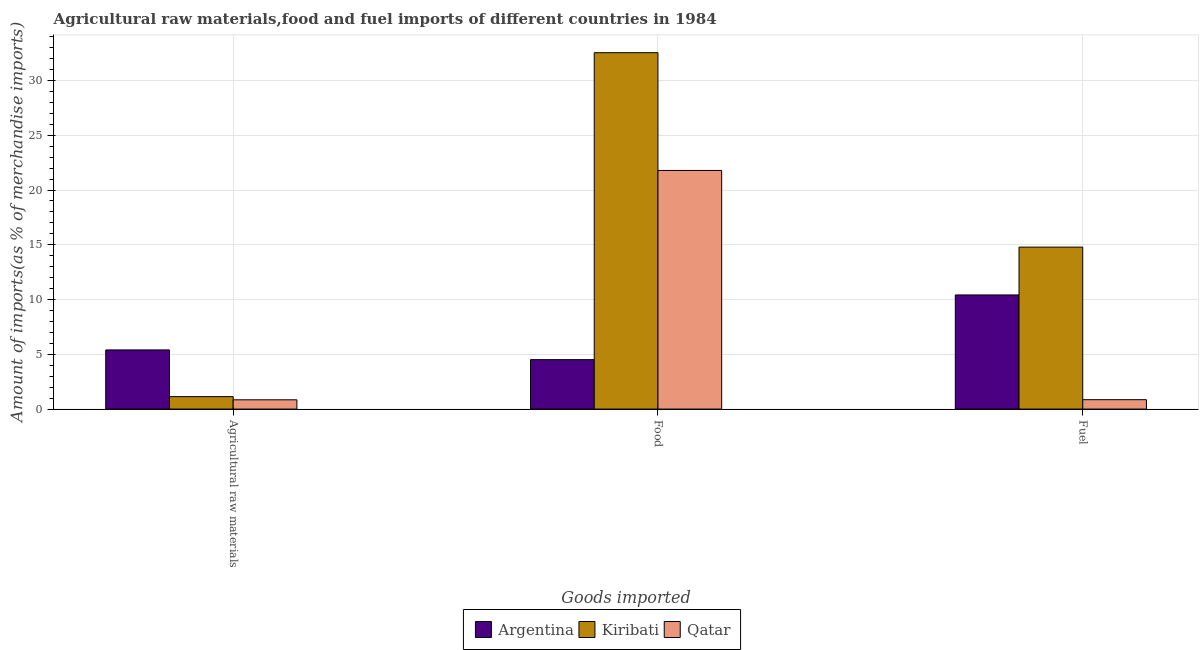How many different coloured bars are there?
Keep it short and to the point. 3. How many bars are there on the 3rd tick from the left?
Keep it short and to the point. 3. How many bars are there on the 2nd tick from the right?
Provide a short and direct response. 3. What is the label of the 1st group of bars from the left?
Your response must be concise. Agricultural raw materials. What is the percentage of fuel imports in Kiribati?
Offer a very short reply. 14.79. Across all countries, what is the maximum percentage of raw materials imports?
Your response must be concise. 5.4. Across all countries, what is the minimum percentage of raw materials imports?
Offer a very short reply. 0.85. In which country was the percentage of raw materials imports minimum?
Make the answer very short. Qatar. What is the total percentage of raw materials imports in the graph?
Keep it short and to the point. 7.39. What is the difference between the percentage of food imports in Kiribati and that in Argentina?
Your answer should be very brief. 28.03. What is the difference between the percentage of food imports in Qatar and the percentage of raw materials imports in Argentina?
Keep it short and to the point. 16.39. What is the average percentage of fuel imports per country?
Provide a succinct answer. 8.69. What is the difference between the percentage of fuel imports and percentage of raw materials imports in Argentina?
Provide a short and direct response. 5.02. In how many countries, is the percentage of food imports greater than 6 %?
Your response must be concise. 2. What is the ratio of the percentage of food imports in Qatar to that in Argentina?
Your answer should be compact. 4.83. Is the difference between the percentage of raw materials imports in Qatar and Kiribati greater than the difference between the percentage of fuel imports in Qatar and Kiribati?
Ensure brevity in your answer.  Yes. What is the difference between the highest and the second highest percentage of raw materials imports?
Keep it short and to the point. 4.26. What is the difference between the highest and the lowest percentage of raw materials imports?
Your response must be concise. 4.55. In how many countries, is the percentage of food imports greater than the average percentage of food imports taken over all countries?
Make the answer very short. 2. What does the 3rd bar from the left in Fuel represents?
Your response must be concise. Qatar. How many bars are there?
Your answer should be very brief. 9. Are the values on the major ticks of Y-axis written in scientific E-notation?
Keep it short and to the point. No. Does the graph contain any zero values?
Ensure brevity in your answer.  No. What is the title of the graph?
Provide a short and direct response. Agricultural raw materials,food and fuel imports of different countries in 1984. Does "Singapore" appear as one of the legend labels in the graph?
Your response must be concise. No. What is the label or title of the X-axis?
Your answer should be very brief. Goods imported. What is the label or title of the Y-axis?
Make the answer very short. Amount of imports(as % of merchandise imports). What is the Amount of imports(as % of merchandise imports) in Argentina in Agricultural raw materials?
Your answer should be compact. 5.4. What is the Amount of imports(as % of merchandise imports) in Kiribati in Agricultural raw materials?
Keep it short and to the point. 1.14. What is the Amount of imports(as % of merchandise imports) in Qatar in Agricultural raw materials?
Offer a very short reply. 0.85. What is the Amount of imports(as % of merchandise imports) of Argentina in Food?
Your response must be concise. 4.51. What is the Amount of imports(as % of merchandise imports) in Kiribati in Food?
Ensure brevity in your answer.  32.54. What is the Amount of imports(as % of merchandise imports) of Qatar in Food?
Give a very brief answer. 21.79. What is the Amount of imports(as % of merchandise imports) of Argentina in Fuel?
Keep it short and to the point. 10.42. What is the Amount of imports(as % of merchandise imports) in Kiribati in Fuel?
Offer a very short reply. 14.79. What is the Amount of imports(as % of merchandise imports) in Qatar in Fuel?
Your answer should be compact. 0.86. Across all Goods imported, what is the maximum Amount of imports(as % of merchandise imports) of Argentina?
Make the answer very short. 10.42. Across all Goods imported, what is the maximum Amount of imports(as % of merchandise imports) in Kiribati?
Make the answer very short. 32.54. Across all Goods imported, what is the maximum Amount of imports(as % of merchandise imports) in Qatar?
Offer a terse response. 21.79. Across all Goods imported, what is the minimum Amount of imports(as % of merchandise imports) of Argentina?
Your answer should be very brief. 4.51. Across all Goods imported, what is the minimum Amount of imports(as % of merchandise imports) of Kiribati?
Keep it short and to the point. 1.14. Across all Goods imported, what is the minimum Amount of imports(as % of merchandise imports) of Qatar?
Keep it short and to the point. 0.85. What is the total Amount of imports(as % of merchandise imports) of Argentina in the graph?
Provide a short and direct response. 20.34. What is the total Amount of imports(as % of merchandise imports) of Kiribati in the graph?
Ensure brevity in your answer.  48.47. What is the total Amount of imports(as % of merchandise imports) in Qatar in the graph?
Provide a succinct answer. 23.49. What is the difference between the Amount of imports(as % of merchandise imports) in Argentina in Agricultural raw materials and that in Food?
Your response must be concise. 0.89. What is the difference between the Amount of imports(as % of merchandise imports) of Kiribati in Agricultural raw materials and that in Food?
Keep it short and to the point. -31.4. What is the difference between the Amount of imports(as % of merchandise imports) of Qatar in Agricultural raw materials and that in Food?
Provide a succinct answer. -20.94. What is the difference between the Amount of imports(as % of merchandise imports) in Argentina in Agricultural raw materials and that in Fuel?
Offer a very short reply. -5.02. What is the difference between the Amount of imports(as % of merchandise imports) of Kiribati in Agricultural raw materials and that in Fuel?
Your answer should be compact. -13.65. What is the difference between the Amount of imports(as % of merchandise imports) in Qatar in Agricultural raw materials and that in Fuel?
Your answer should be compact. -0.01. What is the difference between the Amount of imports(as % of merchandise imports) of Argentina in Food and that in Fuel?
Offer a terse response. -5.91. What is the difference between the Amount of imports(as % of merchandise imports) of Kiribati in Food and that in Fuel?
Your answer should be compact. 17.75. What is the difference between the Amount of imports(as % of merchandise imports) in Qatar in Food and that in Fuel?
Make the answer very short. 20.93. What is the difference between the Amount of imports(as % of merchandise imports) in Argentina in Agricultural raw materials and the Amount of imports(as % of merchandise imports) in Kiribati in Food?
Provide a succinct answer. -27.14. What is the difference between the Amount of imports(as % of merchandise imports) of Argentina in Agricultural raw materials and the Amount of imports(as % of merchandise imports) of Qatar in Food?
Provide a short and direct response. -16.39. What is the difference between the Amount of imports(as % of merchandise imports) of Kiribati in Agricultural raw materials and the Amount of imports(as % of merchandise imports) of Qatar in Food?
Provide a short and direct response. -20.65. What is the difference between the Amount of imports(as % of merchandise imports) in Argentina in Agricultural raw materials and the Amount of imports(as % of merchandise imports) in Kiribati in Fuel?
Your response must be concise. -9.39. What is the difference between the Amount of imports(as % of merchandise imports) in Argentina in Agricultural raw materials and the Amount of imports(as % of merchandise imports) in Qatar in Fuel?
Your answer should be compact. 4.54. What is the difference between the Amount of imports(as % of merchandise imports) of Kiribati in Agricultural raw materials and the Amount of imports(as % of merchandise imports) of Qatar in Fuel?
Your answer should be very brief. 0.28. What is the difference between the Amount of imports(as % of merchandise imports) in Argentina in Food and the Amount of imports(as % of merchandise imports) in Kiribati in Fuel?
Give a very brief answer. -10.27. What is the difference between the Amount of imports(as % of merchandise imports) of Argentina in Food and the Amount of imports(as % of merchandise imports) of Qatar in Fuel?
Your answer should be very brief. 3.66. What is the difference between the Amount of imports(as % of merchandise imports) of Kiribati in Food and the Amount of imports(as % of merchandise imports) of Qatar in Fuel?
Offer a very short reply. 31.68. What is the average Amount of imports(as % of merchandise imports) in Argentina per Goods imported?
Your response must be concise. 6.78. What is the average Amount of imports(as % of merchandise imports) in Kiribati per Goods imported?
Your answer should be very brief. 16.16. What is the average Amount of imports(as % of merchandise imports) in Qatar per Goods imported?
Make the answer very short. 7.83. What is the difference between the Amount of imports(as % of merchandise imports) of Argentina and Amount of imports(as % of merchandise imports) of Kiribati in Agricultural raw materials?
Provide a short and direct response. 4.26. What is the difference between the Amount of imports(as % of merchandise imports) in Argentina and Amount of imports(as % of merchandise imports) in Qatar in Agricultural raw materials?
Your answer should be compact. 4.55. What is the difference between the Amount of imports(as % of merchandise imports) in Kiribati and Amount of imports(as % of merchandise imports) in Qatar in Agricultural raw materials?
Ensure brevity in your answer.  0.29. What is the difference between the Amount of imports(as % of merchandise imports) in Argentina and Amount of imports(as % of merchandise imports) in Kiribati in Food?
Offer a terse response. -28.03. What is the difference between the Amount of imports(as % of merchandise imports) in Argentina and Amount of imports(as % of merchandise imports) in Qatar in Food?
Your answer should be very brief. -17.27. What is the difference between the Amount of imports(as % of merchandise imports) in Kiribati and Amount of imports(as % of merchandise imports) in Qatar in Food?
Your answer should be very brief. 10.75. What is the difference between the Amount of imports(as % of merchandise imports) of Argentina and Amount of imports(as % of merchandise imports) of Kiribati in Fuel?
Ensure brevity in your answer.  -4.37. What is the difference between the Amount of imports(as % of merchandise imports) of Argentina and Amount of imports(as % of merchandise imports) of Qatar in Fuel?
Give a very brief answer. 9.56. What is the difference between the Amount of imports(as % of merchandise imports) in Kiribati and Amount of imports(as % of merchandise imports) in Qatar in Fuel?
Offer a terse response. 13.93. What is the ratio of the Amount of imports(as % of merchandise imports) of Argentina in Agricultural raw materials to that in Food?
Offer a very short reply. 1.2. What is the ratio of the Amount of imports(as % of merchandise imports) of Kiribati in Agricultural raw materials to that in Food?
Your answer should be very brief. 0.04. What is the ratio of the Amount of imports(as % of merchandise imports) of Qatar in Agricultural raw materials to that in Food?
Offer a terse response. 0.04. What is the ratio of the Amount of imports(as % of merchandise imports) of Argentina in Agricultural raw materials to that in Fuel?
Your response must be concise. 0.52. What is the ratio of the Amount of imports(as % of merchandise imports) in Kiribati in Agricultural raw materials to that in Fuel?
Make the answer very short. 0.08. What is the ratio of the Amount of imports(as % of merchandise imports) in Qatar in Agricultural raw materials to that in Fuel?
Give a very brief answer. 0.99. What is the ratio of the Amount of imports(as % of merchandise imports) in Argentina in Food to that in Fuel?
Provide a short and direct response. 0.43. What is the ratio of the Amount of imports(as % of merchandise imports) of Kiribati in Food to that in Fuel?
Your response must be concise. 2.2. What is the ratio of the Amount of imports(as % of merchandise imports) in Qatar in Food to that in Fuel?
Provide a succinct answer. 25.38. What is the difference between the highest and the second highest Amount of imports(as % of merchandise imports) in Argentina?
Provide a short and direct response. 5.02. What is the difference between the highest and the second highest Amount of imports(as % of merchandise imports) in Kiribati?
Provide a succinct answer. 17.75. What is the difference between the highest and the second highest Amount of imports(as % of merchandise imports) of Qatar?
Give a very brief answer. 20.93. What is the difference between the highest and the lowest Amount of imports(as % of merchandise imports) of Argentina?
Give a very brief answer. 5.91. What is the difference between the highest and the lowest Amount of imports(as % of merchandise imports) in Kiribati?
Make the answer very short. 31.4. What is the difference between the highest and the lowest Amount of imports(as % of merchandise imports) in Qatar?
Your response must be concise. 20.94. 